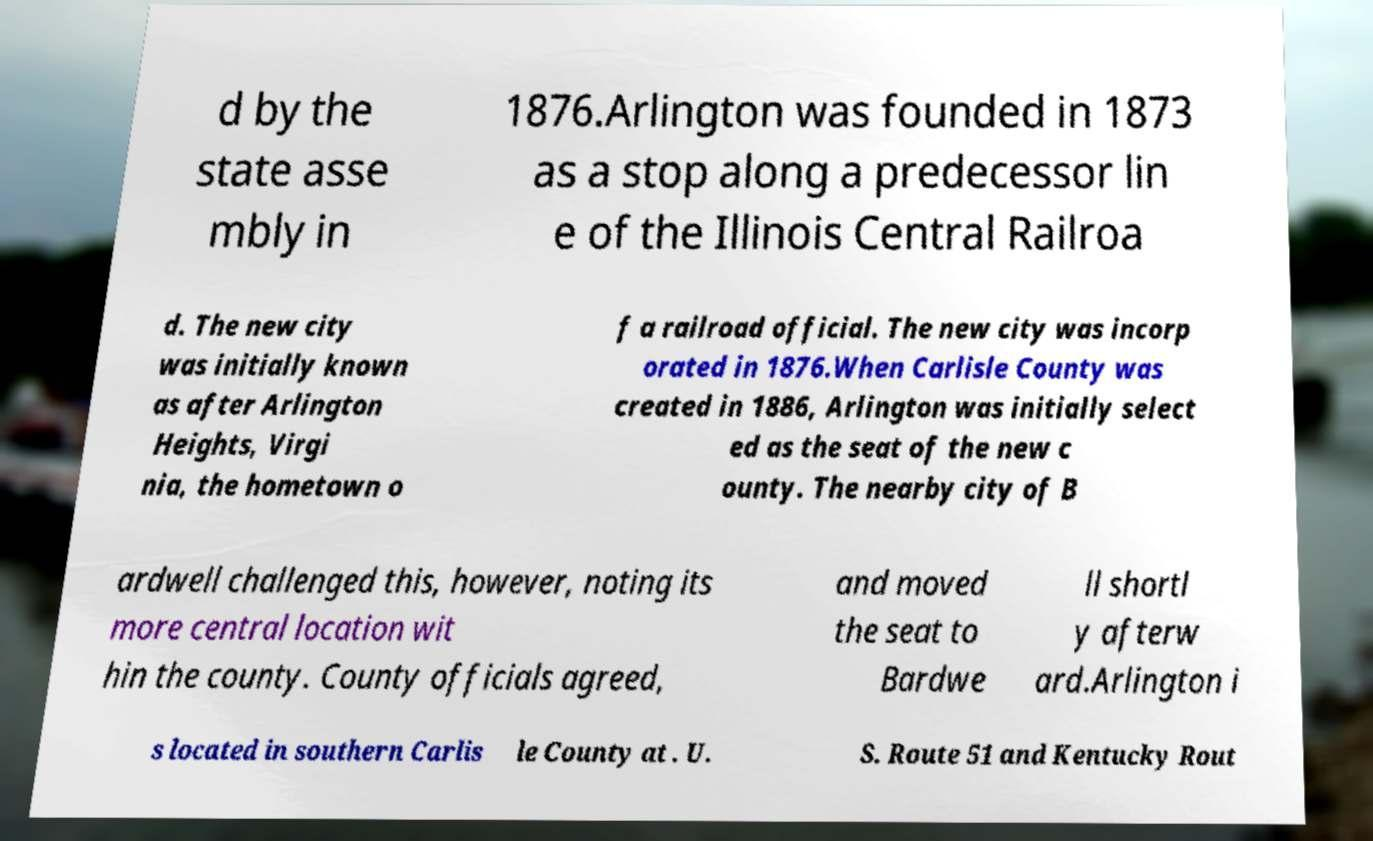I need the written content from this picture converted into text. Can you do that? d by the state asse mbly in 1876.Arlington was founded in 1873 as a stop along a predecessor lin e of the Illinois Central Railroa d. The new city was initially known as after Arlington Heights, Virgi nia, the hometown o f a railroad official. The new city was incorp orated in 1876.When Carlisle County was created in 1886, Arlington was initially select ed as the seat of the new c ounty. The nearby city of B ardwell challenged this, however, noting its more central location wit hin the county. County officials agreed, and moved the seat to Bardwe ll shortl y afterw ard.Arlington i s located in southern Carlis le County at . U. S. Route 51 and Kentucky Rout 